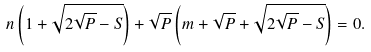Convert formula to latex. <formula><loc_0><loc_0><loc_500><loc_500>n \left ( 1 + \sqrt { 2 \sqrt { P } - S } \right ) + \sqrt { P } \left ( m + \sqrt { P } + \sqrt { 2 \sqrt { P } - S } \right ) = 0 .</formula> 